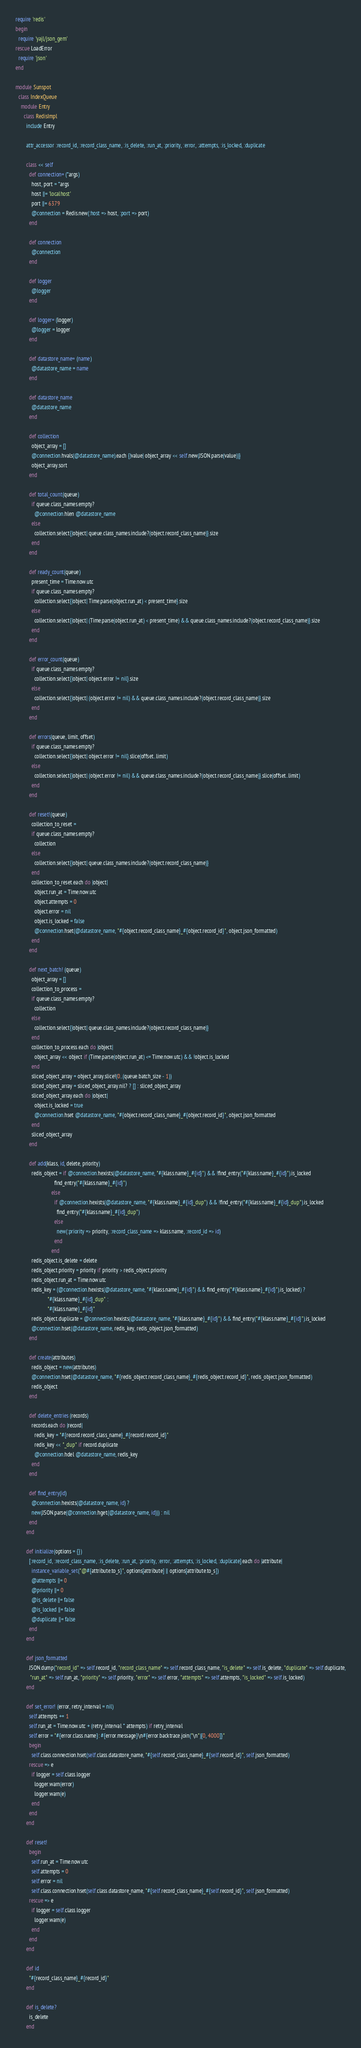Convert code to text. <code><loc_0><loc_0><loc_500><loc_500><_Ruby_>require 'redis'
begin
  require 'yajl/json_gem'
rescue LoadError
  require 'json'
end

module Sunspot
  class IndexQueue
    module Entry
      class RedisImpl
        include Entry

        attr_accessor :record_id, :record_class_name, :is_delete, :run_at, :priority, :error, :attempts, :is_locked, :duplicate

        class << self
          def connection= (*args)
            host, port = *args
            host ||= 'localhost'
            port ||= 6379
            @connection = Redis.new(:host => host, :port => port)
          end

          def connection
            @connection
          end

          def logger
            @logger
          end

          def logger= (logger)
            @logger = logger
          end

          def datastore_name= (name)
            @datastore_name = name
          end

          def datastore_name
            @datastore_name
          end

          def collection
            object_array = []
            @connection.hvals(@datastore_name).each {|value| object_array << self.new(JSON.parse(value))}
            object_array.sort
          end

          def total_count(queue)
            if queue.class_names.empty?
              @connection.hlen @datastore_name
            else
              collection.select{|object| queue.class_names.include?(object.record_class_name)}.size
            end
          end

          def ready_count(queue)
            present_time = Time.now.utc
            if queue.class_names.empty?
              collection.select{|object| Time.parse(object.run_at) < present_time}.size
            else
              collection.select{|object| (Time.parse(object.run_at) < present_time) && queue.class_names.include?(object.record_class_name)}.size
            end
          end

          def error_count(queue)
            if queue.class_names.empty?
              collection.select{|object| object.error != nil}.size
            else
              collection.select{|object| (object.error != nil) && queue.class_names.include?(object.record_class_name)}.size
            end
          end

          def errors(queue, limit, offset)
            if queue.class_names.empty?
              collection.select{|object| object.error != nil}.slice(offset..limit)
            else
              collection.select{|object| (object.error != nil) && queue.class_names.include?(object.record_class_name)}.slice(offset..limit)
            end
          end

          def reset!(queue)
            collection_to_reset =
            if queue.class_names.empty?
              collection
            else
              collection.select{|object| queue.class_names.include?(object.record_class_name)}
            end
            collection_to_reset.each do |object|
              object.run_at = Time.now.utc
              object.attempts = 0
              object.error = nil
              object.is_locked = false
              @connection.hset(@datastore_name, "#{object.record_class_name}_#{object.record_id}", object.json_formatted)
            end
          end

          def next_batch! (queue)
            object_array = []
            collection_to_process =
            if queue.class_names.empty?
              collection
            else
              collection.select{|object| queue.class_names.include?(object.record_class_name)}
            end
            collection_to_process.each do |object|
              object_array << object if (Time.parse(object.run_at) <= Time.now.utc) && !object.is_locked
            end
            sliced_object_array = object_array.slice!(0..(queue.batch_size - 1))
            sliced_object_array = sliced_object_array.nil? ? [] : sliced_object_array
            sliced_object_array.each do |object|
              object.is_locked = true
              @connection.hset @datastore_name, "#{object.record_class_name}_#{object.record_id}", object.json_formatted
            end
            sliced_object_array
          end

          def add(klass, id, delete, priority)
            redis_object = if @connection.hexists(@datastore_name, "#{klass.name}_#{id}") && !find_entry("#{klass.name}_#{id}").is_locked
                             find_entry("#{klass.name}_#{id}")
                           else
                             if @connection.hexists(@datastore_name, "#{klass.name}_#{id}_dup") && !find_entry("#{klass.name}_#{id}_dup").is_locked
                               find_entry("#{klass.name}_#{id}_dup")
                             else
                               new(:priority => priority, :record_class_name => klass.name, :record_id => id)
                             end
                           end
            redis_object.is_delete = delete
            redis_object.priority = priority if priority > redis_object.priority
            redis_object.run_at = Time.now.utc
            redis_key = (@connection.hexists(@datastore_name, "#{klass.name}_#{id}") && find_entry("#{klass.name}_#{id}").is_locked) ?
                        "#{klass.name}_#{id}_dup" :
                        "#{klass.name}_#{id}"
            redis_object.duplicate = @connection.hexists(@datastore_name, "#{klass.name}_#{id}") && find_entry("#{klass.name}_#{id}").is_locked
            @connection.hset(@datastore_name, redis_key, redis_object.json_formatted)
          end

          def create(attributes)
            redis_object = new(attributes)
            @connection.hset(@datastore_name, "#{redis_object.record_class_name}_#{redis_object.record_id}", redis_object.json_formatted)
            redis_object
          end

          def delete_entries (records)
            records.each do |record|
              redis_key = "#{record.record_class_name}_#{record.record_id}"
              redis_key << "_dup" if record.duplicate
              @connection.hdel @datastore_name, redis_key
            end
          end

          def find_entry(id)
            @connection.hexists(@datastore_name, id) ?
            new(JSON.parse(@connection.hget(@datastore_name, id))) : nil
          end
        end

        def initialize(options = {})
          [:record_id, :record_class_name, :is_delete, :run_at, :priority, :error, :attempts, :is_locked, :duplicate].each do |attribute|
            instance_variable_set("@#{attribute.to_s}", options[attribute] || options[attribute.to_s])
            @attempts ||= 0
            @priority ||= 0
            @is_delete ||= false
            @is_locked ||= false
            @duplicate ||= false
          end
        end

        def json_formatted
          JSON.dump("record_id" => self.record_id, "record_class_name" => self.record_class_name, "is_delete" => self.is_delete, "duplicate" => self.duplicate,
           "run_at" => self.run_at, "priority" => self.priority, "error" => self.error, "attempts" => self.attempts, "is_locked" => self.is_locked)
        end

        def set_error! (error, retry_interval = nil)
          self.attempts += 1
          self.run_at = Time.now.utc + (retry_interval * attempts) if retry_interval
          self.error = "#{error.class.name}: #{error.message}\n#{error.backtrace.join("\n")[0, 4000]}"
          begin
            self.class.connection.hset(self.class.datastore_name, "#{self.record_class_name}_#{self.record_id}", self.json_formatted)
          rescue => e
            if logger = self.class.logger
              logger.warn(error)
              logger.warn(e)
            end
          end
        end

        def reset!
          begin
            self.run_at = Time.now.utc
            self.attempts = 0
            self.error = nil
            self.class.connection.hset(self.class.datastore_name, "#{self.record_class_name}_#{self.record_id}", self.json_formatted)
          rescue => e
            if logger = self.class.logger
              logger.warn(e)
            end
          end
        end

        def id
          "#{record_class_name}_#{record_id}"
        end

        def is_delete?
          is_delete
        end
</code> 